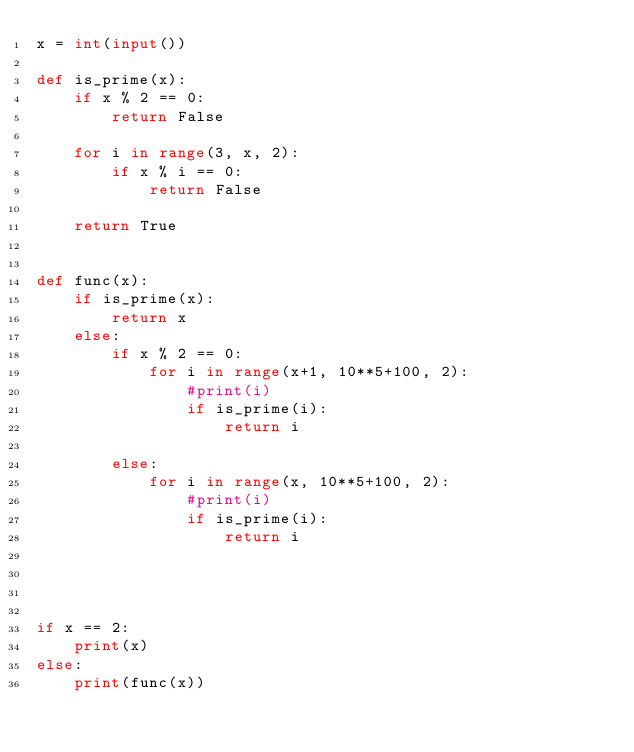Convert code to text. <code><loc_0><loc_0><loc_500><loc_500><_Python_>x = int(input())

def is_prime(x):
    if x % 2 == 0:
        return False

    for i in range(3, x, 2):
        if x % i == 0:
            return False

    return True


def func(x):
    if is_prime(x):
        return x
    else:
        if x % 2 == 0:
            for i in range(x+1, 10**5+100, 2):
                #print(i)
                if is_prime(i):
                    return i

        else:
            for i in range(x, 10**5+100, 2):
                #print(i)
                if is_prime(i):
                    return i




if x == 2:
    print(x)
else:
    print(func(x))</code> 